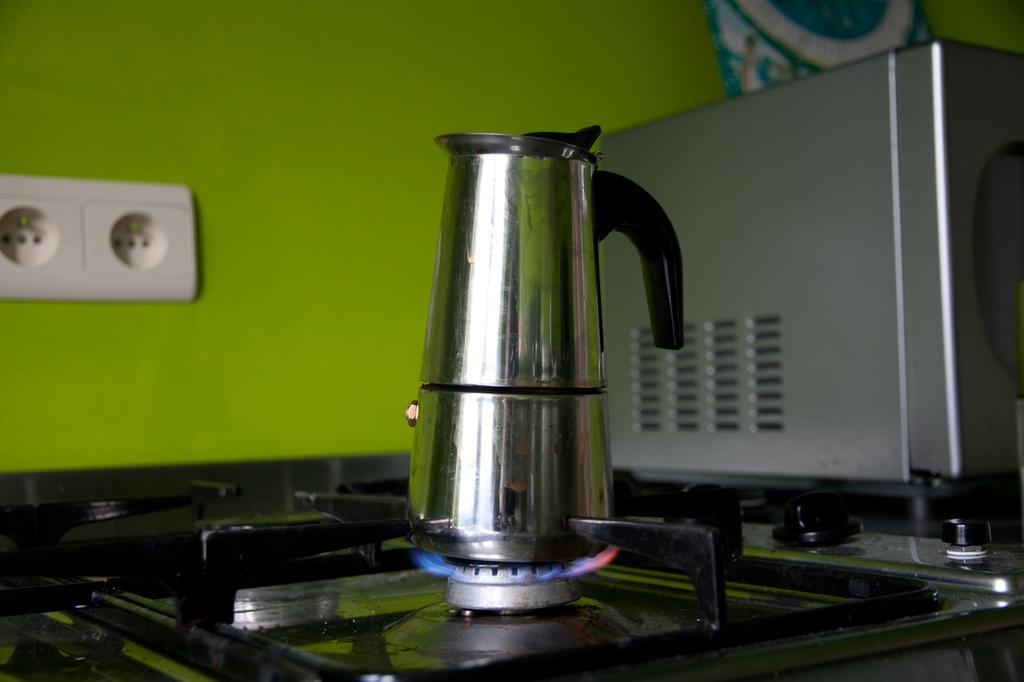What type of jug is visible in the image? There is a stainless steel jug in the image. Where is the stainless steel jug located? The stainless steel jug is on a gas stove. What type of force is being applied to the jug in the image? There is no indication of any force being applied to the jug in the image. 